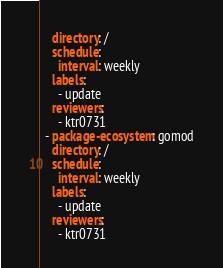<code> <loc_0><loc_0><loc_500><loc_500><_YAML_>    directory: /
    schedule:
      interval: weekly
    labels:
      - update
    reviewers:
      - ktr0731
  - package-ecosystem: gomod
    directory: /
    schedule:
      interval: weekly
    labels:
      - update
    reviewers:
      - ktr0731
</code> 